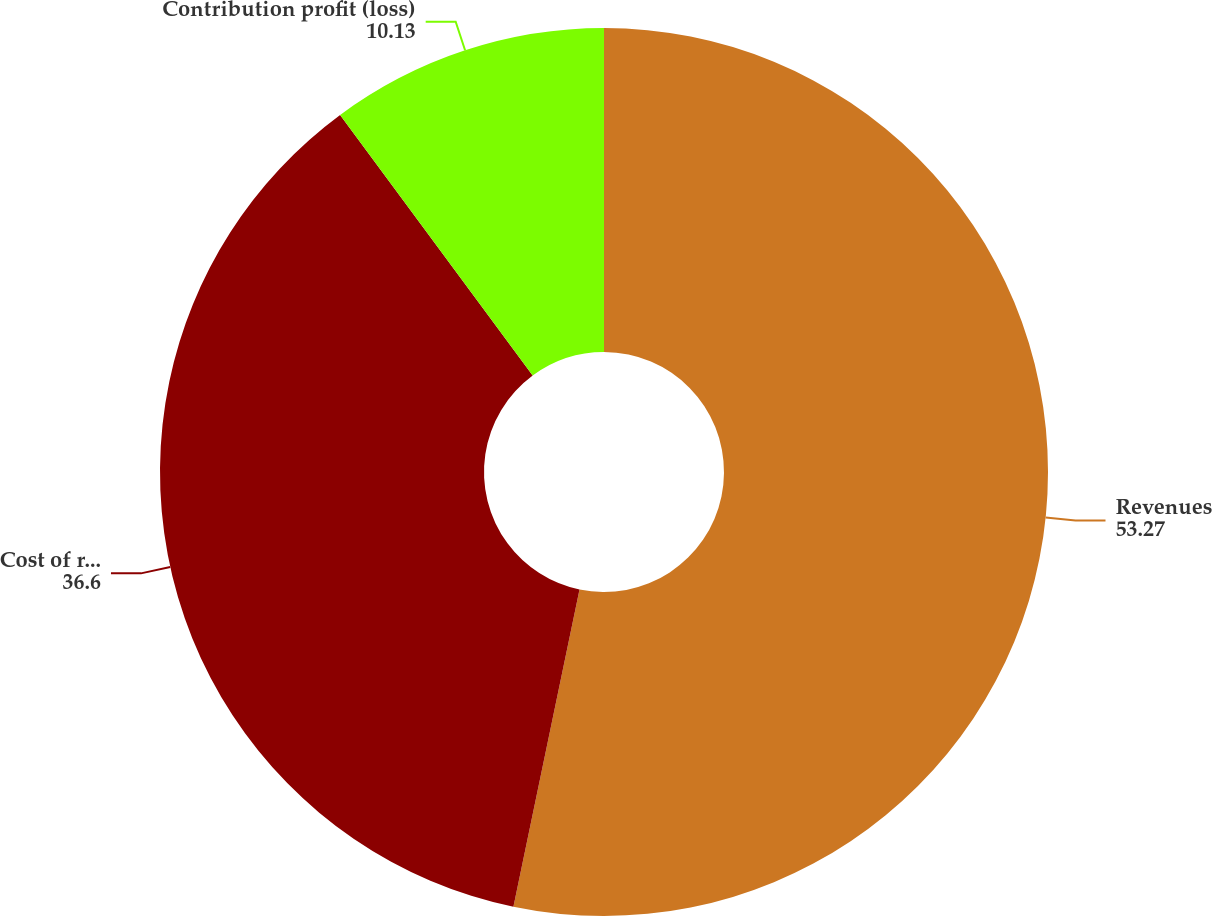<chart> <loc_0><loc_0><loc_500><loc_500><pie_chart><fcel>Revenues<fcel>Cost of revenues<fcel>Contribution profit (loss)<nl><fcel>53.27%<fcel>36.6%<fcel>10.13%<nl></chart> 